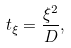<formula> <loc_0><loc_0><loc_500><loc_500>t _ { \xi } = \frac { \xi ^ { 2 } } { D } ,</formula> 